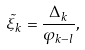Convert formula to latex. <formula><loc_0><loc_0><loc_500><loc_500>\tilde { \xi } _ { k } = \frac { \Delta _ { k } } { \varphi _ { k - l } } ,</formula> 